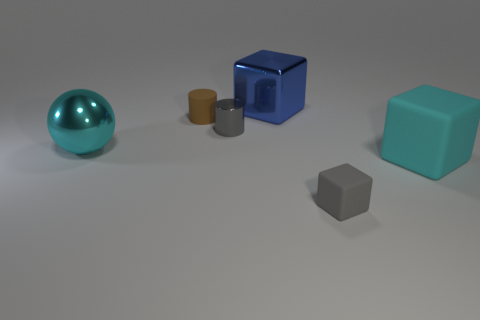What size is the shiny sphere that is the same color as the large matte cube?
Offer a terse response. Large. The big cyan object that is to the right of the tiny matte thing that is to the left of the gray matte object is made of what material?
Provide a succinct answer. Rubber. Do the gray block and the large thing right of the gray block have the same material?
Provide a short and direct response. Yes. How many objects are either tiny gray objects to the left of the blue thing or big blocks?
Provide a succinct answer. 3. Are there any big objects of the same color as the big metallic sphere?
Offer a very short reply. Yes. Is the shape of the tiny gray metal thing the same as the matte thing that is behind the big sphere?
Provide a succinct answer. Yes. What number of large things are in front of the tiny brown matte thing and on the right side of the tiny metallic cylinder?
Provide a short and direct response. 1. There is a large cyan object that is the same shape as the gray matte thing; what material is it?
Provide a short and direct response. Rubber. How big is the gray thing left of the big metal object behind the large cyan ball?
Provide a short and direct response. Small. Are any cyan balls visible?
Offer a terse response. Yes. 